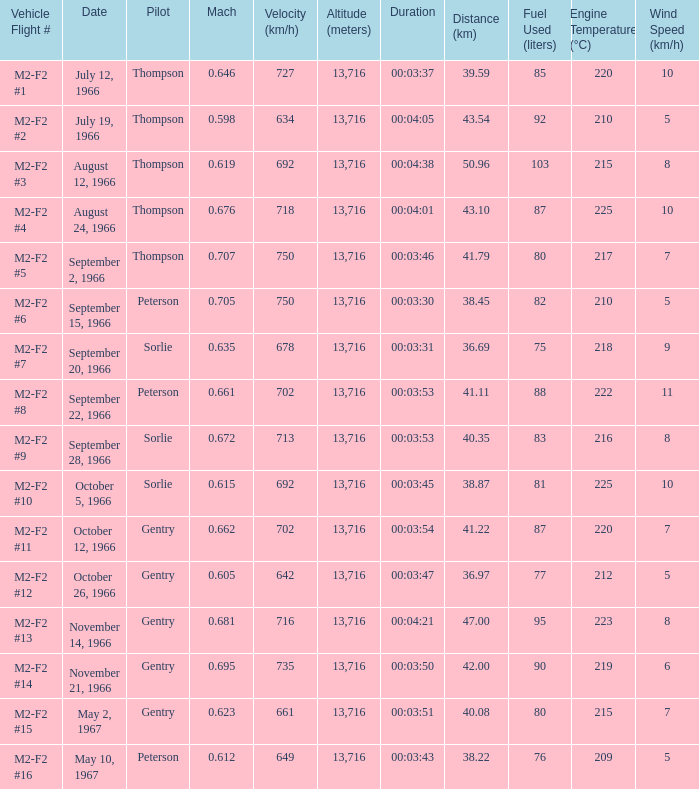Can you give me this table as a dict? {'header': ['Vehicle Flight #', 'Date', 'Pilot', 'Mach', 'Velocity (km/h)', 'Altitude (meters)', 'Duration', 'Distance (km)', 'Fuel Used (liters)', 'Engine Temperature (°C)', 'Wind Speed (km/h)'], 'rows': [['M2-F2 #1', 'July 12, 1966', 'Thompson', '0.646', '727', '13,716', '00:03:37', '39.59', '85', '220', '10'], ['M2-F2 #2', 'July 19, 1966', 'Thompson', '0.598', '634', '13,716', '00:04:05', '43.54', '92', '210', '5'], ['M2-F2 #3', 'August 12, 1966', 'Thompson', '0.619', '692', '13,716', '00:04:38', '50.96', '103', '215', '8'], ['M2-F2 #4', 'August 24, 1966', 'Thompson', '0.676', '718', '13,716', '00:04:01', '43.10', '87', '225', '10'], ['M2-F2 #5', 'September 2, 1966', 'Thompson', '0.707', '750', '13,716', '00:03:46', '41.79', '80', '217', '7'], ['M2-F2 #6', 'September 15, 1966', 'Peterson', '0.705', '750', '13,716', '00:03:30', '38.45', '82', '210', '5'], ['M2-F2 #7', 'September 20, 1966', 'Sorlie', '0.635', '678', '13,716', '00:03:31', '36.69', '75', '218', '9'], ['M2-F2 #8', 'September 22, 1966', 'Peterson', '0.661', '702', '13,716', '00:03:53', '41.11', '88', '222', '11'], ['M2-F2 #9', 'September 28, 1966', 'Sorlie', '0.672', '713', '13,716', '00:03:53', '40.35', '83', '216', '8'], ['M2-F2 #10', 'October 5, 1966', 'Sorlie', '0.615', '692', '13,716', '00:03:45', '38.87', '81', '225', '10'], ['M2-F2 #11', 'October 12, 1966', 'Gentry', '0.662', '702', '13,716', '00:03:54', '41.22', '87', '220', '7'], ['M2-F2 #12', 'October 26, 1966', 'Gentry', '0.605', '642', '13,716', '00:03:47', '36.97', '77', '212', '5'], ['M2-F2 #13', 'November 14, 1966', 'Gentry', '0.681', '716', '13,716', '00:04:21', '47.00', '95', '223', '8'], ['M2-F2 #14', 'November 21, 1966', 'Gentry', '0.695', '735', '13,716', '00:03:50', '42.00', '90', '219', '6'], ['M2-F2 #15', 'May 2, 1967', 'Gentry', '0.623', '661', '13,716', '00:03:51', '40.08', '80', '215', '7'], ['M2-F2 #16', 'May 10, 1967', 'Peterson', '0.612', '649', '13,716', '00:03:43', '38.22', '76', '209', '5']]} What Date has a Mach of 0.662? October 12, 1966. 